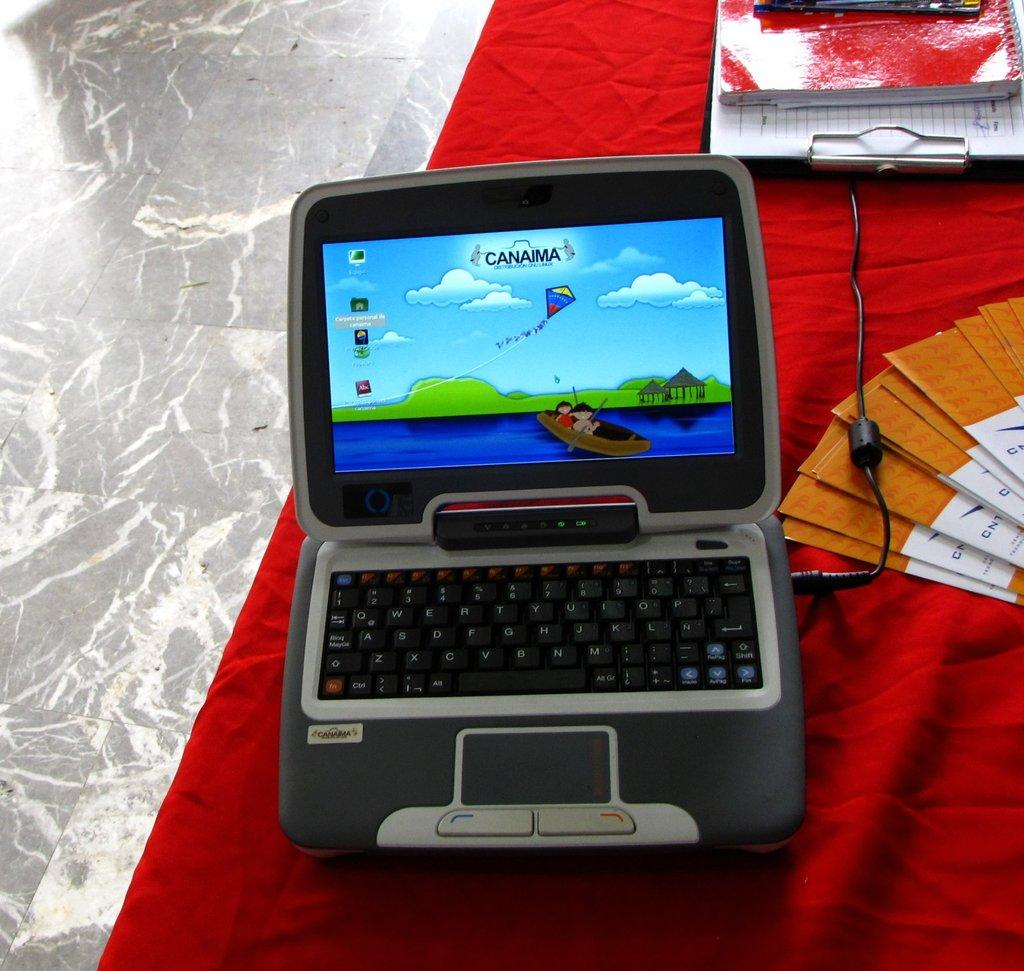What type of electronic device is present in the image? There is a toy laptop in the image. What other items can be seen in the image? There are cards, a book, and a writing pad in the image. What is the surface on which the objects are placed? The objects are placed on a cloth. What can be seen below the cloth? The floor is visible in the image. What type of magic trick is the uncle performing with the leaf in the image? There is no uncle or leaf present in the image; it only features a toy laptop, cards, a book, a writing pad, a cloth, and a visible floor. 